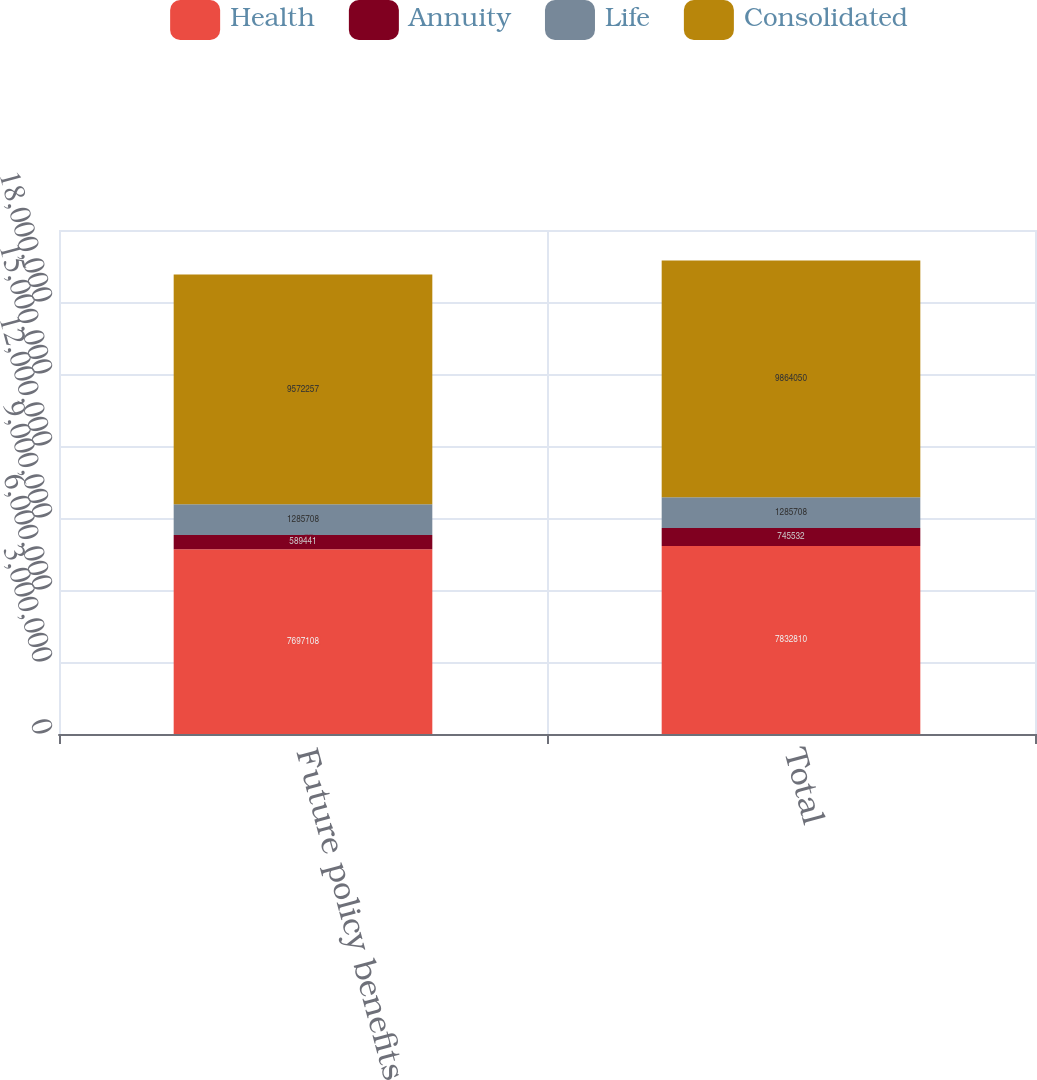Convert chart to OTSL. <chart><loc_0><loc_0><loc_500><loc_500><stacked_bar_chart><ecel><fcel>Future policy benefits<fcel>Total<nl><fcel>Health<fcel>7.69711e+06<fcel>7.83281e+06<nl><fcel>Annuity<fcel>589441<fcel>745532<nl><fcel>Life<fcel>1.28571e+06<fcel>1.28571e+06<nl><fcel>Consolidated<fcel>9.57226e+06<fcel>9.86405e+06<nl></chart> 